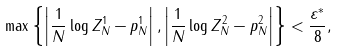<formula> <loc_0><loc_0><loc_500><loc_500>\max \left \{ \left | \frac { 1 } { N } \log Z _ { N } ^ { 1 } - p _ { N } ^ { 1 } \right | , \left | \frac { 1 } { N } \log Z _ { N } ^ { 2 } - p _ { N } ^ { 2 } \right | \right \} < \frac { \varepsilon ^ { * } } { 8 } ,</formula> 